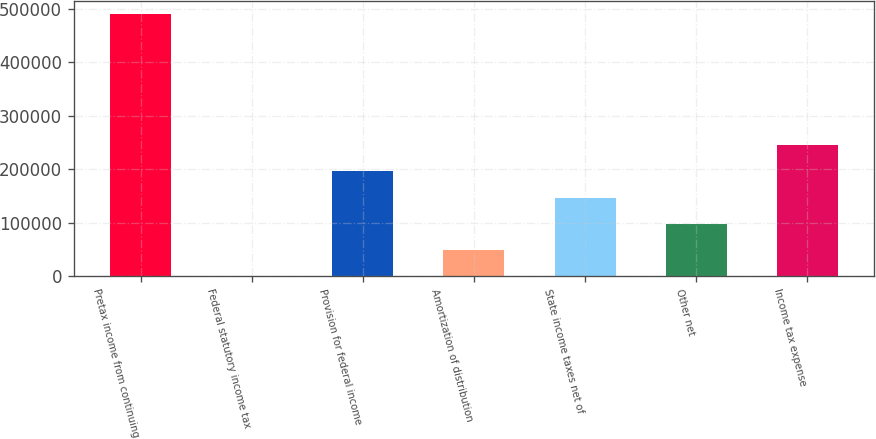Convert chart to OTSL. <chart><loc_0><loc_0><loc_500><loc_500><bar_chart><fcel>Pretax income from continuing<fcel>Federal statutory income tax<fcel>Provision for federal income<fcel>Amortization of distribution<fcel>State income taxes net of<fcel>Other net<fcel>Income tax expense<nl><fcel>489518<fcel>35<fcel>195828<fcel>48983.3<fcel>146880<fcel>97931.6<fcel>244776<nl></chart> 